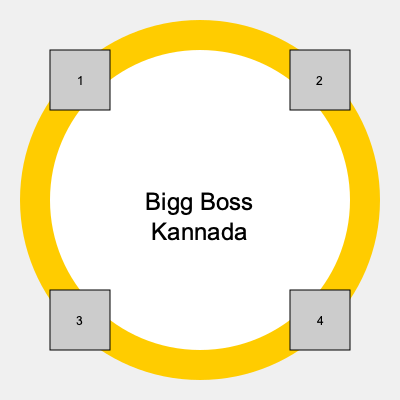In the Bigg Boss Kannada logo puzzle, contestants' photos need to be arranged in the four corners. If Sudeep (host) is always placed in position 1, and the most recent season's winner goes in position 4, in which position should the runner-up's photo be placed to maintain symmetry? To solve this puzzle, let's follow these steps:

1. Understand the given information:
   - Sudeep (host) is always in position 1 (top-left corner)
   - The most recent season's winner is in position 4 (bottom-right corner)

2. Consider the principle of symmetry:
   - In a symmetrical arrangement, opposite corners should have similar importance

3. Analyze the remaining positions:
   - Position 2 is in the top-right corner
   - Position 3 is in the bottom-left corner

4. Apply logical reasoning:
   - Since the host (most important) is in position 1, the next most important person (runner-up) should be in the diagonally opposite corner
   - This maintains symmetry and balances the importance of the individuals

5. Conclude:
   - The runner-up should be placed in position 2 (top-right corner)

This arrangement creates a balanced and symmetrical design, with the host and runner-up on the top row, and two other contestants (including the winner) on the bottom row.
Answer: Position 2 (top-right corner) 